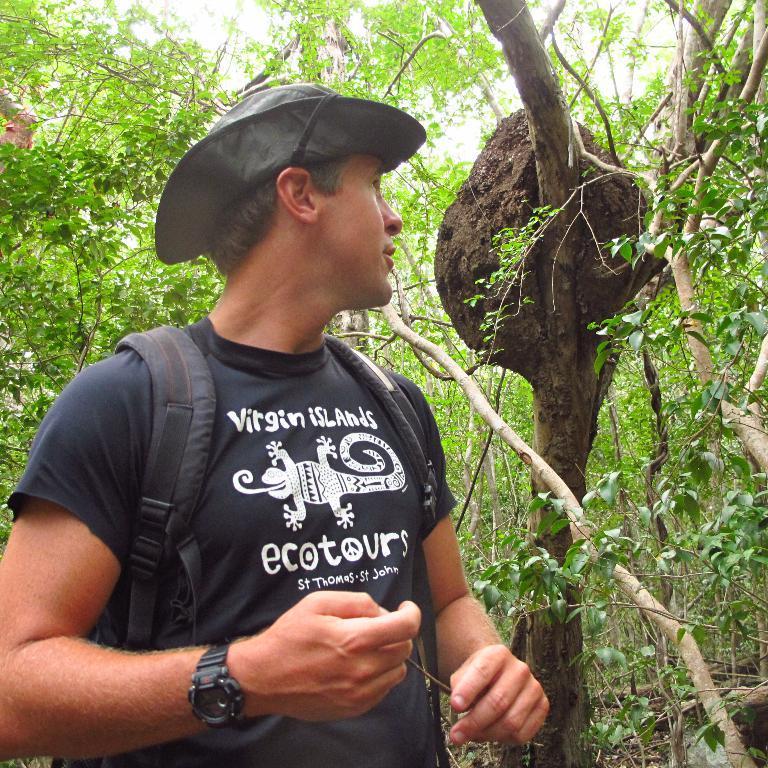Could you give a brief overview of what you see in this image? In this image, we can see a person wearing clothes and hat. In the background, we can see some trees. 